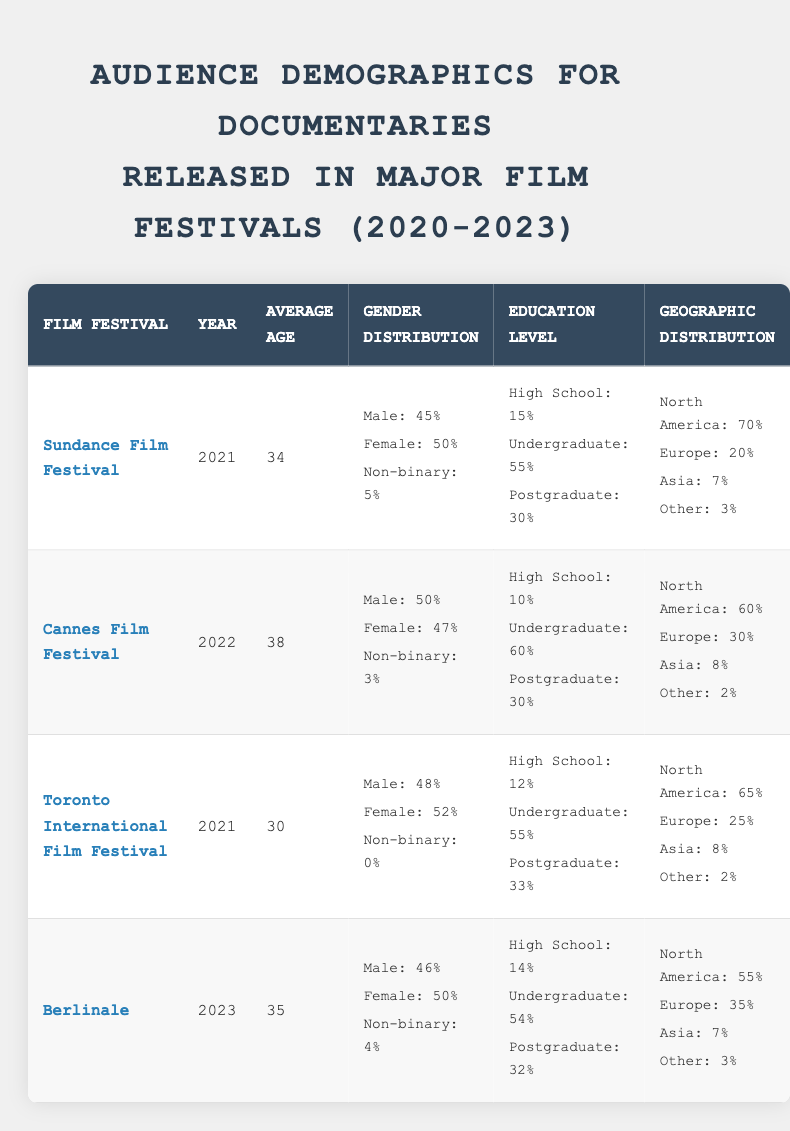What was the average age of the audience at the Cannes Film Festival in 2022? From the table, we can see that the average age is listed under the Cannes Film Festival row for the year 2022. It states that the average age is 38.
Answer: 38 Which film festival had the highest percentage of audience members from North America? Looking at the geographic distribution for each film festival listed, Sundance has 70% from North America, which is higher than any of the others (Cannes: 60%, Toronto: 65%, Berlinale: 55%).
Answer: Sundance Film Festival What is the gender distribution of the audience at the Toronto International Film Festival? From the Toronto International Film Festival row, the gender distribution specifies that there are 48% male, 52% female, and 0% non-binary audience members.
Answer: Male: 48%, Female: 52%, Non-binary: 0% Is the educational level of the audience more inclined towards postgraduate education at the Berlinale compared to the Cannes Film Festival? At the Berlinale, the postgraduate level is 32%, and at Cannes, it is 30%. This shows the Berlinale has a slightly higher percentage of postgraduate-educated audience members compared to Cannes.
Answer: Yes What is the difference in average age between the Sundance Film Festival and the Berlinale? The average age at Sundance is 34 and at Berlinale, it is 35. The difference can be calculated as 35 - 34 = 1.
Answer: 1 